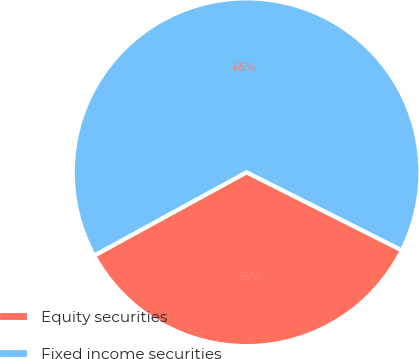Convert chart to OTSL. <chart><loc_0><loc_0><loc_500><loc_500><pie_chart><fcel>Equity securities<fcel>Fixed income securities<nl><fcel>34.62%<fcel>65.38%<nl></chart> 